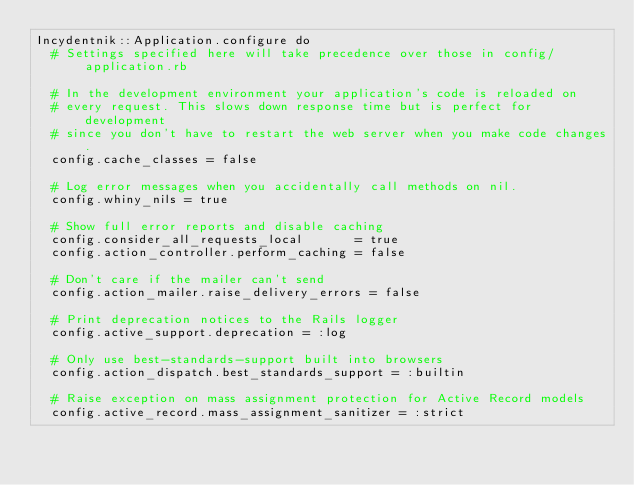Convert code to text. <code><loc_0><loc_0><loc_500><loc_500><_Ruby_>Incydentnik::Application.configure do
  # Settings specified here will take precedence over those in config/application.rb

  # In the development environment your application's code is reloaded on
  # every request. This slows down response time but is perfect for development
  # since you don't have to restart the web server when you make code changes.
  config.cache_classes = false

  # Log error messages when you accidentally call methods on nil.
  config.whiny_nils = true

  # Show full error reports and disable caching
  config.consider_all_requests_local       = true
  config.action_controller.perform_caching = false

  # Don't care if the mailer can't send
  config.action_mailer.raise_delivery_errors = false

  # Print deprecation notices to the Rails logger
  config.active_support.deprecation = :log

  # Only use best-standards-support built into browsers
  config.action_dispatch.best_standards_support = :builtin

  # Raise exception on mass assignment protection for Active Record models
  config.active_record.mass_assignment_sanitizer = :strict
</code> 